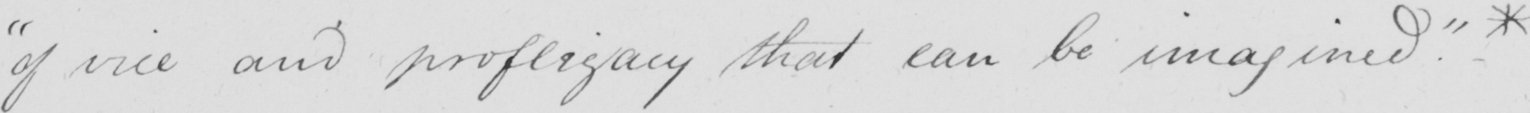Can you tell me what this handwritten text says? " of vice and profligacy that can be imagined . " * 